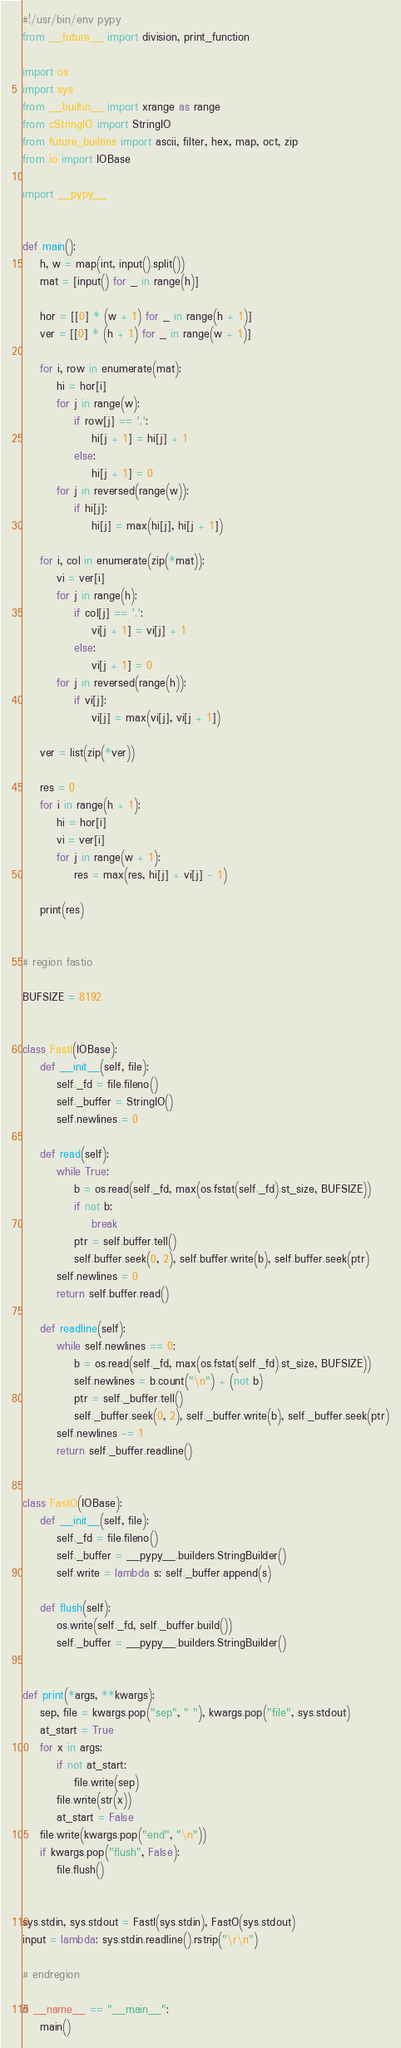Convert code to text. <code><loc_0><loc_0><loc_500><loc_500><_Python_>#!/usr/bin/env pypy
from __future__ import division, print_function

import os
import sys
from __builtin__ import xrange as range
from cStringIO import StringIO
from future_builtins import ascii, filter, hex, map, oct, zip
from io import IOBase

import __pypy__


def main():
    h, w = map(int, input().split())
    mat = [input() for _ in range(h)]

    hor = [[0] * (w + 1) for _ in range(h + 1)]
    ver = [[0] * (h + 1) for _ in range(w + 1)]

    for i, row in enumerate(mat):
        hi = hor[i]
        for j in range(w):
            if row[j] == '.':
                hi[j + 1] = hi[j] + 1
            else:
                hi[j + 1] = 0
        for j in reversed(range(w)):
            if hi[j]:
                hi[j] = max(hi[j], hi[j + 1])

    for i, col in enumerate(zip(*mat)):
        vi = ver[i]
        for j in range(h):
            if col[j] == '.':
                vi[j + 1] = vi[j] + 1
            else:
                vi[j + 1] = 0
        for j in reversed(range(h)):
            if vi[j]:
                vi[j] = max(vi[j], vi[j + 1])

    ver = list(zip(*ver))

    res = 0
    for i in range(h + 1):
        hi = hor[i]
        vi = ver[i]
        for j in range(w + 1):
            res = max(res, hi[j] + vi[j] - 1)

    print(res)


# region fastio

BUFSIZE = 8192


class FastI(IOBase):
    def __init__(self, file):
        self._fd = file.fileno()
        self._buffer = StringIO()
        self.newlines = 0

    def read(self):
        while True:
            b = os.read(self._fd, max(os.fstat(self._fd).st_size, BUFSIZE))
            if not b:
                break
            ptr = self.buffer.tell()
            self.buffer.seek(0, 2), self.buffer.write(b), self.buffer.seek(ptr)
        self.newlines = 0
        return self.buffer.read()

    def readline(self):
        while self.newlines == 0:
            b = os.read(self._fd, max(os.fstat(self._fd).st_size, BUFSIZE))
            self.newlines = b.count("\n") + (not b)
            ptr = self._buffer.tell()
            self._buffer.seek(0, 2), self._buffer.write(b), self._buffer.seek(ptr)
        self.newlines -= 1
        return self._buffer.readline()


class FastO(IOBase):
    def __init__(self, file):
        self._fd = file.fileno()
        self._buffer = __pypy__.builders.StringBuilder()
        self.write = lambda s: self._buffer.append(s)

    def flush(self):
        os.write(self._fd, self._buffer.build())
        self._buffer = __pypy__.builders.StringBuilder()


def print(*args, **kwargs):
    sep, file = kwargs.pop("sep", " "), kwargs.pop("file", sys.stdout)
    at_start = True
    for x in args:
        if not at_start:
            file.write(sep)
        file.write(str(x))
        at_start = False
    file.write(kwargs.pop("end", "\n"))
    if kwargs.pop("flush", False):
        file.flush()


sys.stdin, sys.stdout = FastI(sys.stdin), FastO(sys.stdout)
input = lambda: sys.stdin.readline().rstrip("\r\n")

# endregion

if __name__ == "__main__":
    main()
</code> 